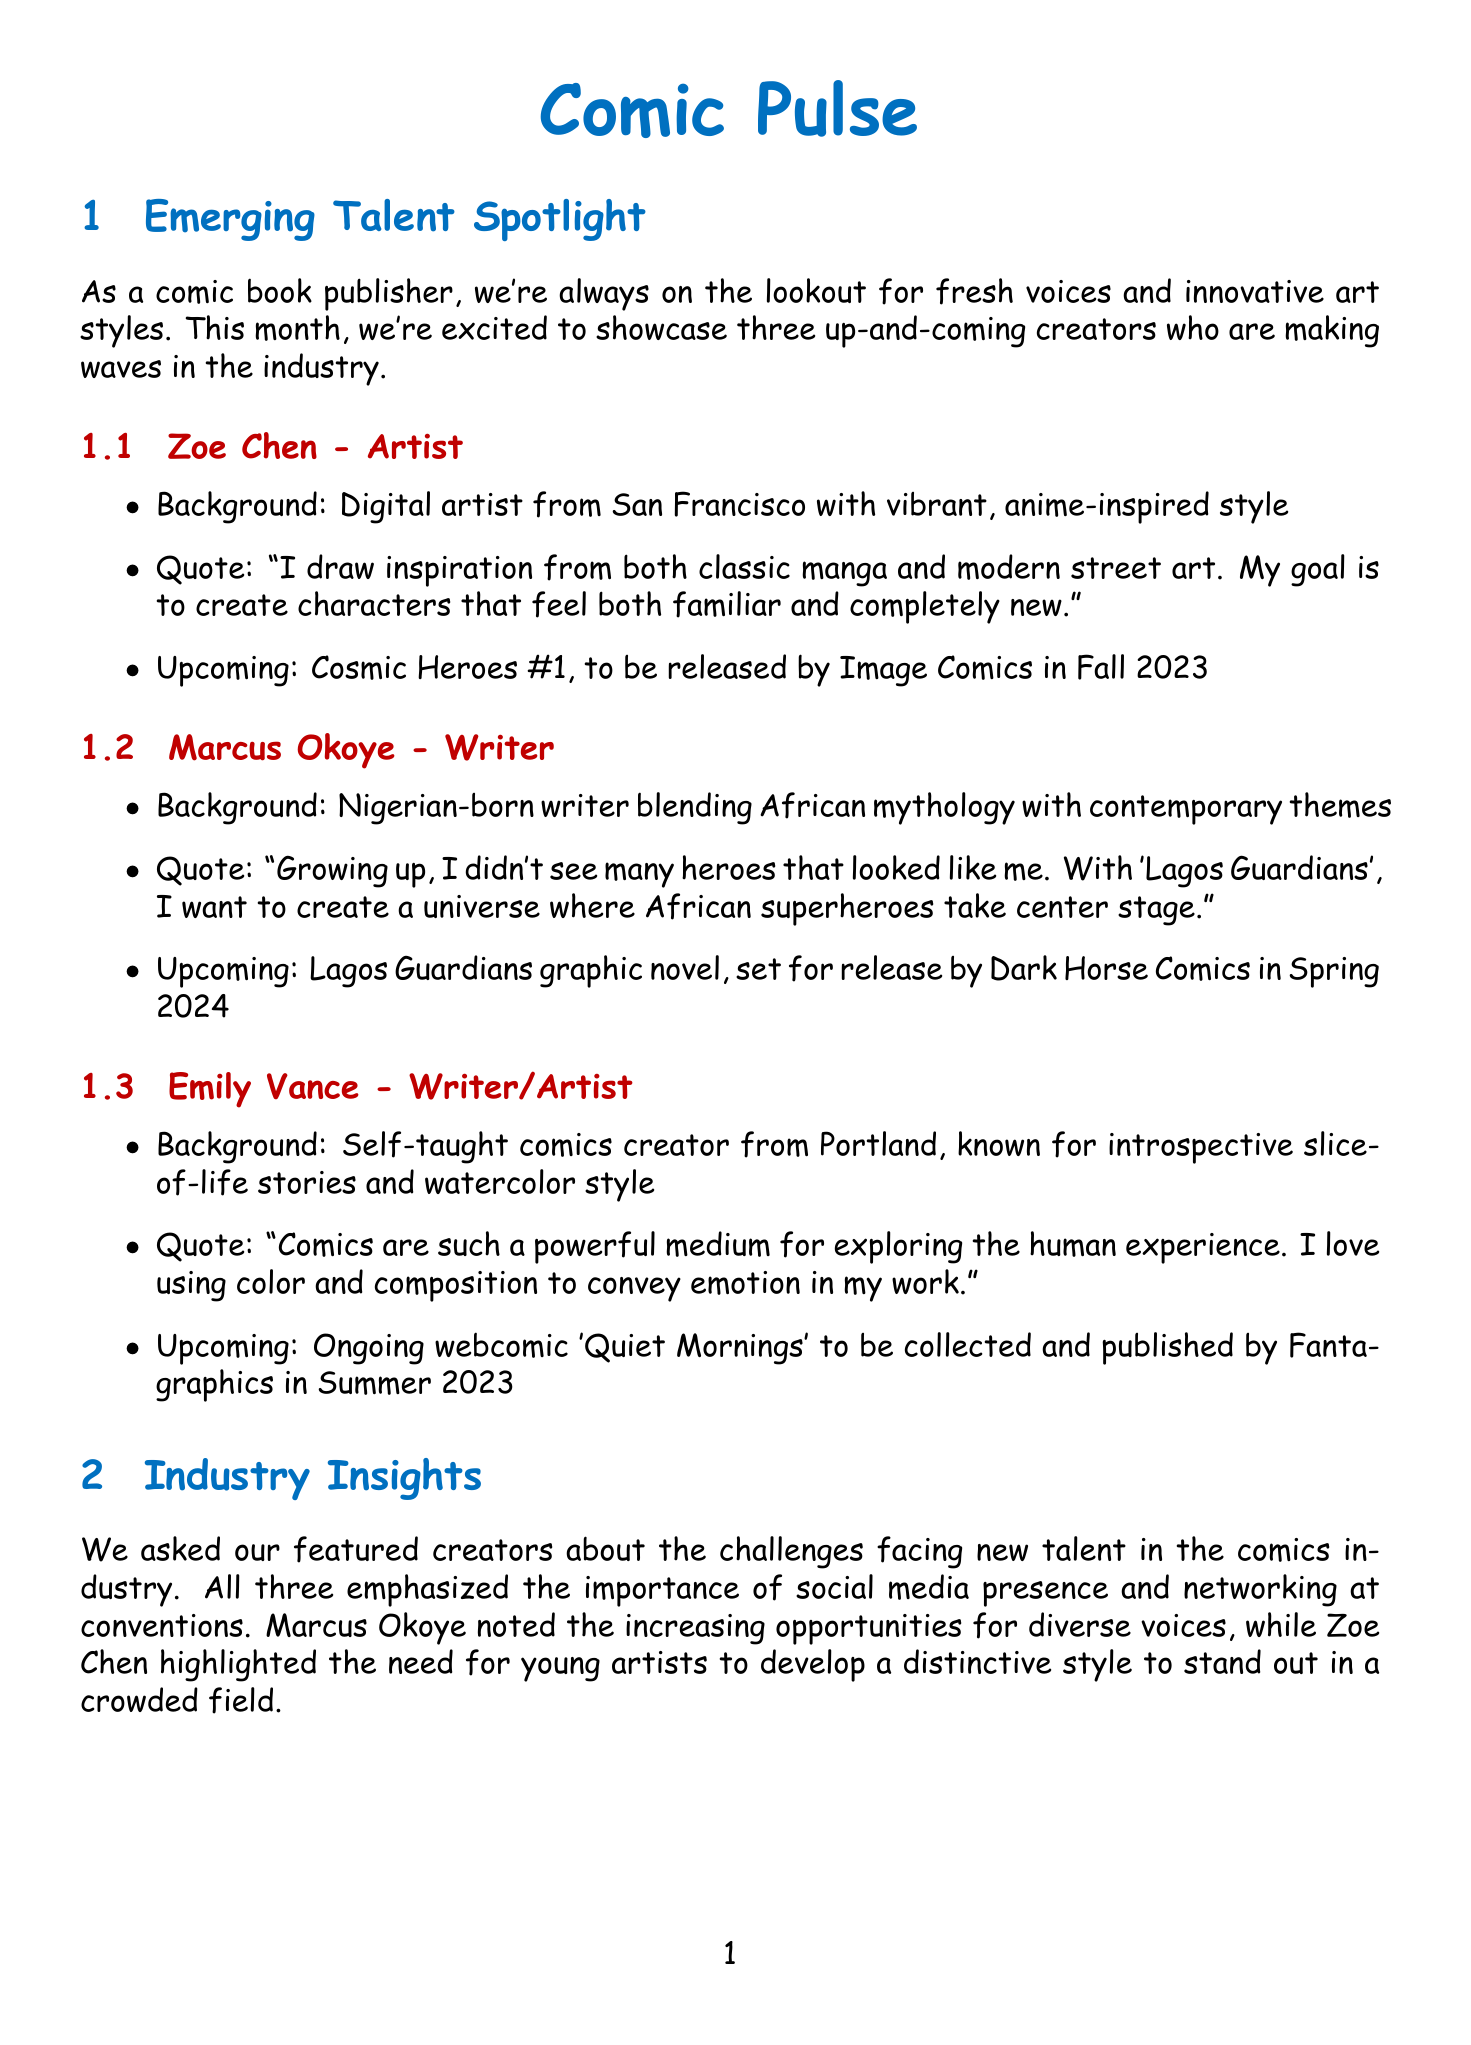What is the title of the spotlight section? The document features a section titled "Emerging Talent Spotlight".
Answer: Emerging Talent Spotlight Who is the artist featured in this month's spotlight? The first featured creator in the spotlight section is Zoe Chen.
Answer: Zoe Chen What upcoming project will Marcus Okoye release? Marcus Okoye's upcoming project mentioned is the "Lagos Guardians" graphic novel.
Answer: Lagos Guardians graphic novel When is Emily Vance's collected edition being published? The document states that Emily Vance's collected edition will be published in Summer 2023.
Answer: Summer 2023 Which medium does Emily Vance primarily utilize in her comics? Emily Vance is known for her distinctive watercolor style.
Answer: Watercolor style What theme does Marcus Okoye integrate into his superhero narratives? Marcus Okoye blends African mythology with contemporary themes in his work.
Answer: African mythology What did Zoe Chen emphasize for young artists to stand out? Zoe Chen highlighted the need for young artists to develop a distinctive style.
Answer: Distinctive style What is the publisher's pick this month? The publisher's pick this month is Emily Vance's "Quiet Mornings".
Answer: Quiet Mornings 